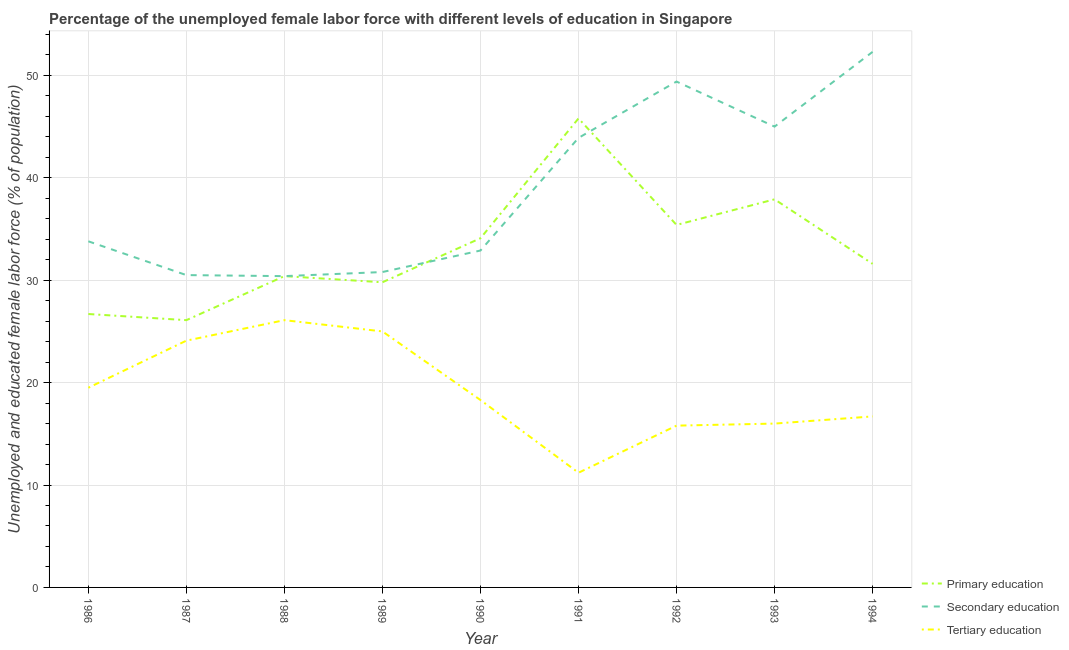What is the percentage of female labor force who received secondary education in 1986?
Your answer should be compact. 33.8. Across all years, what is the maximum percentage of female labor force who received secondary education?
Your answer should be compact. 52.3. Across all years, what is the minimum percentage of female labor force who received secondary education?
Your answer should be very brief. 30.4. In which year was the percentage of female labor force who received primary education maximum?
Your answer should be compact. 1991. What is the total percentage of female labor force who received tertiary education in the graph?
Offer a very short reply. 172.7. What is the difference between the percentage of female labor force who received primary education in 1988 and that in 1991?
Make the answer very short. -15.4. What is the difference between the percentage of female labor force who received tertiary education in 1988 and the percentage of female labor force who received primary education in 1987?
Offer a very short reply. 0. What is the average percentage of female labor force who received primary education per year?
Keep it short and to the point. 33.09. In the year 1990, what is the difference between the percentage of female labor force who received primary education and percentage of female labor force who received tertiary education?
Your answer should be very brief. 15.8. What is the ratio of the percentage of female labor force who received primary education in 1986 to that in 1994?
Your answer should be compact. 0.84. Is the difference between the percentage of female labor force who received tertiary education in 1987 and 1988 greater than the difference between the percentage of female labor force who received primary education in 1987 and 1988?
Keep it short and to the point. Yes. What is the difference between the highest and the second highest percentage of female labor force who received tertiary education?
Give a very brief answer. 1.1. What is the difference between the highest and the lowest percentage of female labor force who received secondary education?
Your answer should be compact. 21.9. In how many years, is the percentage of female labor force who received tertiary education greater than the average percentage of female labor force who received tertiary education taken over all years?
Provide a short and direct response. 4. Is the percentage of female labor force who received tertiary education strictly greater than the percentage of female labor force who received secondary education over the years?
Provide a short and direct response. No. Does the graph contain any zero values?
Provide a short and direct response. No. How are the legend labels stacked?
Offer a very short reply. Vertical. What is the title of the graph?
Your answer should be compact. Percentage of the unemployed female labor force with different levels of education in Singapore. What is the label or title of the X-axis?
Offer a terse response. Year. What is the label or title of the Y-axis?
Offer a terse response. Unemployed and educated female labor force (% of population). What is the Unemployed and educated female labor force (% of population) of Primary education in 1986?
Give a very brief answer. 26.7. What is the Unemployed and educated female labor force (% of population) of Secondary education in 1986?
Provide a short and direct response. 33.8. What is the Unemployed and educated female labor force (% of population) in Primary education in 1987?
Make the answer very short. 26.1. What is the Unemployed and educated female labor force (% of population) of Secondary education in 1987?
Keep it short and to the point. 30.5. What is the Unemployed and educated female labor force (% of population) in Tertiary education in 1987?
Give a very brief answer. 24.1. What is the Unemployed and educated female labor force (% of population) of Primary education in 1988?
Make the answer very short. 30.4. What is the Unemployed and educated female labor force (% of population) in Secondary education in 1988?
Your response must be concise. 30.4. What is the Unemployed and educated female labor force (% of population) in Tertiary education in 1988?
Your response must be concise. 26.1. What is the Unemployed and educated female labor force (% of population) in Primary education in 1989?
Your response must be concise. 29.8. What is the Unemployed and educated female labor force (% of population) of Secondary education in 1989?
Your answer should be very brief. 30.8. What is the Unemployed and educated female labor force (% of population) in Primary education in 1990?
Provide a short and direct response. 34.1. What is the Unemployed and educated female labor force (% of population) of Secondary education in 1990?
Your answer should be compact. 32.9. What is the Unemployed and educated female labor force (% of population) of Tertiary education in 1990?
Offer a terse response. 18.3. What is the Unemployed and educated female labor force (% of population) in Primary education in 1991?
Your answer should be very brief. 45.8. What is the Unemployed and educated female labor force (% of population) in Secondary education in 1991?
Your response must be concise. 43.9. What is the Unemployed and educated female labor force (% of population) in Tertiary education in 1991?
Offer a terse response. 11.2. What is the Unemployed and educated female labor force (% of population) in Primary education in 1992?
Make the answer very short. 35.4. What is the Unemployed and educated female labor force (% of population) of Secondary education in 1992?
Your answer should be compact. 49.4. What is the Unemployed and educated female labor force (% of population) of Tertiary education in 1992?
Offer a terse response. 15.8. What is the Unemployed and educated female labor force (% of population) of Primary education in 1993?
Offer a very short reply. 37.9. What is the Unemployed and educated female labor force (% of population) in Secondary education in 1993?
Your answer should be compact. 45. What is the Unemployed and educated female labor force (% of population) in Primary education in 1994?
Offer a very short reply. 31.6. What is the Unemployed and educated female labor force (% of population) of Secondary education in 1994?
Offer a terse response. 52.3. What is the Unemployed and educated female labor force (% of population) of Tertiary education in 1994?
Keep it short and to the point. 16.7. Across all years, what is the maximum Unemployed and educated female labor force (% of population) of Primary education?
Your answer should be compact. 45.8. Across all years, what is the maximum Unemployed and educated female labor force (% of population) in Secondary education?
Provide a succinct answer. 52.3. Across all years, what is the maximum Unemployed and educated female labor force (% of population) of Tertiary education?
Your answer should be very brief. 26.1. Across all years, what is the minimum Unemployed and educated female labor force (% of population) of Primary education?
Your answer should be compact. 26.1. Across all years, what is the minimum Unemployed and educated female labor force (% of population) in Secondary education?
Offer a terse response. 30.4. Across all years, what is the minimum Unemployed and educated female labor force (% of population) of Tertiary education?
Your response must be concise. 11.2. What is the total Unemployed and educated female labor force (% of population) of Primary education in the graph?
Your answer should be very brief. 297.8. What is the total Unemployed and educated female labor force (% of population) of Secondary education in the graph?
Ensure brevity in your answer.  349. What is the total Unemployed and educated female labor force (% of population) of Tertiary education in the graph?
Provide a succinct answer. 172.7. What is the difference between the Unemployed and educated female labor force (% of population) in Secondary education in 1986 and that in 1987?
Your answer should be compact. 3.3. What is the difference between the Unemployed and educated female labor force (% of population) of Primary education in 1986 and that in 1988?
Offer a terse response. -3.7. What is the difference between the Unemployed and educated female labor force (% of population) in Secondary education in 1986 and that in 1988?
Give a very brief answer. 3.4. What is the difference between the Unemployed and educated female labor force (% of population) of Tertiary education in 1986 and that in 1988?
Your answer should be very brief. -6.6. What is the difference between the Unemployed and educated female labor force (% of population) of Secondary education in 1986 and that in 1989?
Your answer should be compact. 3. What is the difference between the Unemployed and educated female labor force (% of population) of Tertiary education in 1986 and that in 1989?
Provide a succinct answer. -5.5. What is the difference between the Unemployed and educated female labor force (% of population) in Primary education in 1986 and that in 1990?
Your answer should be compact. -7.4. What is the difference between the Unemployed and educated female labor force (% of population) in Primary education in 1986 and that in 1991?
Ensure brevity in your answer.  -19.1. What is the difference between the Unemployed and educated female labor force (% of population) of Tertiary education in 1986 and that in 1991?
Your answer should be compact. 8.3. What is the difference between the Unemployed and educated female labor force (% of population) of Primary education in 1986 and that in 1992?
Offer a very short reply. -8.7. What is the difference between the Unemployed and educated female labor force (% of population) in Secondary education in 1986 and that in 1992?
Your answer should be very brief. -15.6. What is the difference between the Unemployed and educated female labor force (% of population) in Secondary education in 1986 and that in 1993?
Your answer should be compact. -11.2. What is the difference between the Unemployed and educated female labor force (% of population) of Tertiary education in 1986 and that in 1993?
Your answer should be very brief. 3.5. What is the difference between the Unemployed and educated female labor force (% of population) in Secondary education in 1986 and that in 1994?
Provide a short and direct response. -18.5. What is the difference between the Unemployed and educated female labor force (% of population) in Secondary education in 1987 and that in 1988?
Ensure brevity in your answer.  0.1. What is the difference between the Unemployed and educated female labor force (% of population) of Tertiary education in 1987 and that in 1988?
Keep it short and to the point. -2. What is the difference between the Unemployed and educated female labor force (% of population) in Secondary education in 1987 and that in 1989?
Make the answer very short. -0.3. What is the difference between the Unemployed and educated female labor force (% of population) in Tertiary education in 1987 and that in 1989?
Keep it short and to the point. -0.9. What is the difference between the Unemployed and educated female labor force (% of population) in Primary education in 1987 and that in 1990?
Your answer should be very brief. -8. What is the difference between the Unemployed and educated female labor force (% of population) in Primary education in 1987 and that in 1991?
Offer a terse response. -19.7. What is the difference between the Unemployed and educated female labor force (% of population) in Primary education in 1987 and that in 1992?
Keep it short and to the point. -9.3. What is the difference between the Unemployed and educated female labor force (% of population) in Secondary education in 1987 and that in 1992?
Keep it short and to the point. -18.9. What is the difference between the Unemployed and educated female labor force (% of population) in Tertiary education in 1987 and that in 1993?
Make the answer very short. 8.1. What is the difference between the Unemployed and educated female labor force (% of population) of Primary education in 1987 and that in 1994?
Offer a terse response. -5.5. What is the difference between the Unemployed and educated female labor force (% of population) in Secondary education in 1987 and that in 1994?
Your answer should be very brief. -21.8. What is the difference between the Unemployed and educated female labor force (% of population) of Primary education in 1988 and that in 1989?
Make the answer very short. 0.6. What is the difference between the Unemployed and educated female labor force (% of population) in Primary education in 1988 and that in 1990?
Ensure brevity in your answer.  -3.7. What is the difference between the Unemployed and educated female labor force (% of population) in Tertiary education in 1988 and that in 1990?
Keep it short and to the point. 7.8. What is the difference between the Unemployed and educated female labor force (% of population) of Primary education in 1988 and that in 1991?
Make the answer very short. -15.4. What is the difference between the Unemployed and educated female labor force (% of population) of Secondary education in 1988 and that in 1991?
Keep it short and to the point. -13.5. What is the difference between the Unemployed and educated female labor force (% of population) of Tertiary education in 1988 and that in 1991?
Provide a succinct answer. 14.9. What is the difference between the Unemployed and educated female labor force (% of population) in Primary education in 1988 and that in 1992?
Give a very brief answer. -5. What is the difference between the Unemployed and educated female labor force (% of population) of Tertiary education in 1988 and that in 1992?
Offer a very short reply. 10.3. What is the difference between the Unemployed and educated female labor force (% of population) in Secondary education in 1988 and that in 1993?
Keep it short and to the point. -14.6. What is the difference between the Unemployed and educated female labor force (% of population) in Primary education in 1988 and that in 1994?
Give a very brief answer. -1.2. What is the difference between the Unemployed and educated female labor force (% of population) of Secondary education in 1988 and that in 1994?
Offer a very short reply. -21.9. What is the difference between the Unemployed and educated female labor force (% of population) in Tertiary education in 1989 and that in 1990?
Offer a terse response. 6.7. What is the difference between the Unemployed and educated female labor force (% of population) of Secondary education in 1989 and that in 1991?
Make the answer very short. -13.1. What is the difference between the Unemployed and educated female labor force (% of population) in Tertiary education in 1989 and that in 1991?
Ensure brevity in your answer.  13.8. What is the difference between the Unemployed and educated female labor force (% of population) in Secondary education in 1989 and that in 1992?
Your answer should be compact. -18.6. What is the difference between the Unemployed and educated female labor force (% of population) of Tertiary education in 1989 and that in 1992?
Keep it short and to the point. 9.2. What is the difference between the Unemployed and educated female labor force (% of population) in Primary education in 1989 and that in 1993?
Your response must be concise. -8.1. What is the difference between the Unemployed and educated female labor force (% of population) in Secondary education in 1989 and that in 1994?
Give a very brief answer. -21.5. What is the difference between the Unemployed and educated female labor force (% of population) of Primary education in 1990 and that in 1991?
Provide a short and direct response. -11.7. What is the difference between the Unemployed and educated female labor force (% of population) of Secondary education in 1990 and that in 1992?
Offer a terse response. -16.5. What is the difference between the Unemployed and educated female labor force (% of population) of Tertiary education in 1990 and that in 1992?
Offer a terse response. 2.5. What is the difference between the Unemployed and educated female labor force (% of population) of Primary education in 1990 and that in 1993?
Ensure brevity in your answer.  -3.8. What is the difference between the Unemployed and educated female labor force (% of population) in Secondary education in 1990 and that in 1993?
Your answer should be compact. -12.1. What is the difference between the Unemployed and educated female labor force (% of population) of Tertiary education in 1990 and that in 1993?
Give a very brief answer. 2.3. What is the difference between the Unemployed and educated female labor force (% of population) in Secondary education in 1990 and that in 1994?
Give a very brief answer. -19.4. What is the difference between the Unemployed and educated female labor force (% of population) in Tertiary education in 1991 and that in 1992?
Ensure brevity in your answer.  -4.6. What is the difference between the Unemployed and educated female labor force (% of population) in Primary education in 1991 and that in 1993?
Keep it short and to the point. 7.9. What is the difference between the Unemployed and educated female labor force (% of population) of Secondary education in 1991 and that in 1994?
Ensure brevity in your answer.  -8.4. What is the difference between the Unemployed and educated female labor force (% of population) in Primary education in 1992 and that in 1993?
Keep it short and to the point. -2.5. What is the difference between the Unemployed and educated female labor force (% of population) in Secondary education in 1992 and that in 1994?
Provide a succinct answer. -2.9. What is the difference between the Unemployed and educated female labor force (% of population) in Tertiary education in 1992 and that in 1994?
Give a very brief answer. -0.9. What is the difference between the Unemployed and educated female labor force (% of population) in Primary education in 1986 and the Unemployed and educated female labor force (% of population) in Tertiary education in 1987?
Make the answer very short. 2.6. What is the difference between the Unemployed and educated female labor force (% of population) in Primary education in 1986 and the Unemployed and educated female labor force (% of population) in Secondary education in 1988?
Your response must be concise. -3.7. What is the difference between the Unemployed and educated female labor force (% of population) in Primary education in 1986 and the Unemployed and educated female labor force (% of population) in Tertiary education in 1988?
Your answer should be compact. 0.6. What is the difference between the Unemployed and educated female labor force (% of population) in Primary education in 1986 and the Unemployed and educated female labor force (% of population) in Tertiary education in 1989?
Provide a short and direct response. 1.7. What is the difference between the Unemployed and educated female labor force (% of population) in Secondary education in 1986 and the Unemployed and educated female labor force (% of population) in Tertiary education in 1989?
Provide a short and direct response. 8.8. What is the difference between the Unemployed and educated female labor force (% of population) in Primary education in 1986 and the Unemployed and educated female labor force (% of population) in Secondary education in 1991?
Your answer should be compact. -17.2. What is the difference between the Unemployed and educated female labor force (% of population) of Secondary education in 1986 and the Unemployed and educated female labor force (% of population) of Tertiary education in 1991?
Give a very brief answer. 22.6. What is the difference between the Unemployed and educated female labor force (% of population) of Primary education in 1986 and the Unemployed and educated female labor force (% of population) of Secondary education in 1992?
Provide a succinct answer. -22.7. What is the difference between the Unemployed and educated female labor force (% of population) in Primary education in 1986 and the Unemployed and educated female labor force (% of population) in Tertiary education in 1992?
Ensure brevity in your answer.  10.9. What is the difference between the Unemployed and educated female labor force (% of population) of Primary education in 1986 and the Unemployed and educated female labor force (% of population) of Secondary education in 1993?
Give a very brief answer. -18.3. What is the difference between the Unemployed and educated female labor force (% of population) in Primary education in 1986 and the Unemployed and educated female labor force (% of population) in Tertiary education in 1993?
Offer a terse response. 10.7. What is the difference between the Unemployed and educated female labor force (% of population) of Secondary education in 1986 and the Unemployed and educated female labor force (% of population) of Tertiary education in 1993?
Offer a terse response. 17.8. What is the difference between the Unemployed and educated female labor force (% of population) of Primary education in 1986 and the Unemployed and educated female labor force (% of population) of Secondary education in 1994?
Offer a very short reply. -25.6. What is the difference between the Unemployed and educated female labor force (% of population) of Primary education in 1987 and the Unemployed and educated female labor force (% of population) of Secondary education in 1988?
Your answer should be compact. -4.3. What is the difference between the Unemployed and educated female labor force (% of population) of Primary education in 1987 and the Unemployed and educated female labor force (% of population) of Secondary education in 1989?
Make the answer very short. -4.7. What is the difference between the Unemployed and educated female labor force (% of population) of Primary education in 1987 and the Unemployed and educated female labor force (% of population) of Tertiary education in 1989?
Keep it short and to the point. 1.1. What is the difference between the Unemployed and educated female labor force (% of population) of Secondary education in 1987 and the Unemployed and educated female labor force (% of population) of Tertiary education in 1989?
Make the answer very short. 5.5. What is the difference between the Unemployed and educated female labor force (% of population) in Primary education in 1987 and the Unemployed and educated female labor force (% of population) in Tertiary education in 1990?
Provide a short and direct response. 7.8. What is the difference between the Unemployed and educated female labor force (% of population) of Primary education in 1987 and the Unemployed and educated female labor force (% of population) of Secondary education in 1991?
Keep it short and to the point. -17.8. What is the difference between the Unemployed and educated female labor force (% of population) of Primary education in 1987 and the Unemployed and educated female labor force (% of population) of Tertiary education in 1991?
Your response must be concise. 14.9. What is the difference between the Unemployed and educated female labor force (% of population) of Secondary education in 1987 and the Unemployed and educated female labor force (% of population) of Tertiary education in 1991?
Give a very brief answer. 19.3. What is the difference between the Unemployed and educated female labor force (% of population) of Primary education in 1987 and the Unemployed and educated female labor force (% of population) of Secondary education in 1992?
Your response must be concise. -23.3. What is the difference between the Unemployed and educated female labor force (% of population) of Secondary education in 1987 and the Unemployed and educated female labor force (% of population) of Tertiary education in 1992?
Provide a short and direct response. 14.7. What is the difference between the Unemployed and educated female labor force (% of population) of Primary education in 1987 and the Unemployed and educated female labor force (% of population) of Secondary education in 1993?
Make the answer very short. -18.9. What is the difference between the Unemployed and educated female labor force (% of population) of Secondary education in 1987 and the Unemployed and educated female labor force (% of population) of Tertiary education in 1993?
Keep it short and to the point. 14.5. What is the difference between the Unemployed and educated female labor force (% of population) of Primary education in 1987 and the Unemployed and educated female labor force (% of population) of Secondary education in 1994?
Make the answer very short. -26.2. What is the difference between the Unemployed and educated female labor force (% of population) of Secondary education in 1987 and the Unemployed and educated female labor force (% of population) of Tertiary education in 1994?
Offer a terse response. 13.8. What is the difference between the Unemployed and educated female labor force (% of population) in Primary education in 1988 and the Unemployed and educated female labor force (% of population) in Tertiary education in 1989?
Offer a terse response. 5.4. What is the difference between the Unemployed and educated female labor force (% of population) in Secondary education in 1988 and the Unemployed and educated female labor force (% of population) in Tertiary education in 1990?
Your response must be concise. 12.1. What is the difference between the Unemployed and educated female labor force (% of population) of Primary education in 1988 and the Unemployed and educated female labor force (% of population) of Secondary education in 1992?
Keep it short and to the point. -19. What is the difference between the Unemployed and educated female labor force (% of population) in Primary education in 1988 and the Unemployed and educated female labor force (% of population) in Tertiary education in 1992?
Offer a very short reply. 14.6. What is the difference between the Unemployed and educated female labor force (% of population) of Secondary education in 1988 and the Unemployed and educated female labor force (% of population) of Tertiary education in 1992?
Make the answer very short. 14.6. What is the difference between the Unemployed and educated female labor force (% of population) of Primary education in 1988 and the Unemployed and educated female labor force (% of population) of Secondary education in 1993?
Your answer should be compact. -14.6. What is the difference between the Unemployed and educated female labor force (% of population) of Primary education in 1988 and the Unemployed and educated female labor force (% of population) of Secondary education in 1994?
Provide a succinct answer. -21.9. What is the difference between the Unemployed and educated female labor force (% of population) in Primary education in 1989 and the Unemployed and educated female labor force (% of population) in Tertiary education in 1990?
Provide a succinct answer. 11.5. What is the difference between the Unemployed and educated female labor force (% of population) in Secondary education in 1989 and the Unemployed and educated female labor force (% of population) in Tertiary education in 1990?
Offer a very short reply. 12.5. What is the difference between the Unemployed and educated female labor force (% of population) of Primary education in 1989 and the Unemployed and educated female labor force (% of population) of Secondary education in 1991?
Your answer should be compact. -14.1. What is the difference between the Unemployed and educated female labor force (% of population) in Primary education in 1989 and the Unemployed and educated female labor force (% of population) in Tertiary education in 1991?
Offer a terse response. 18.6. What is the difference between the Unemployed and educated female labor force (% of population) of Secondary education in 1989 and the Unemployed and educated female labor force (% of population) of Tertiary education in 1991?
Give a very brief answer. 19.6. What is the difference between the Unemployed and educated female labor force (% of population) in Primary education in 1989 and the Unemployed and educated female labor force (% of population) in Secondary education in 1992?
Your answer should be compact. -19.6. What is the difference between the Unemployed and educated female labor force (% of population) of Primary education in 1989 and the Unemployed and educated female labor force (% of population) of Tertiary education in 1992?
Provide a short and direct response. 14. What is the difference between the Unemployed and educated female labor force (% of population) of Secondary education in 1989 and the Unemployed and educated female labor force (% of population) of Tertiary education in 1992?
Your response must be concise. 15. What is the difference between the Unemployed and educated female labor force (% of population) of Primary education in 1989 and the Unemployed and educated female labor force (% of population) of Secondary education in 1993?
Your answer should be compact. -15.2. What is the difference between the Unemployed and educated female labor force (% of population) of Primary education in 1989 and the Unemployed and educated female labor force (% of population) of Tertiary education in 1993?
Make the answer very short. 13.8. What is the difference between the Unemployed and educated female labor force (% of population) of Secondary education in 1989 and the Unemployed and educated female labor force (% of population) of Tertiary education in 1993?
Make the answer very short. 14.8. What is the difference between the Unemployed and educated female labor force (% of population) of Primary education in 1989 and the Unemployed and educated female labor force (% of population) of Secondary education in 1994?
Your response must be concise. -22.5. What is the difference between the Unemployed and educated female labor force (% of population) in Primary education in 1989 and the Unemployed and educated female labor force (% of population) in Tertiary education in 1994?
Your answer should be compact. 13.1. What is the difference between the Unemployed and educated female labor force (% of population) in Primary education in 1990 and the Unemployed and educated female labor force (% of population) in Secondary education in 1991?
Offer a terse response. -9.8. What is the difference between the Unemployed and educated female labor force (% of population) of Primary education in 1990 and the Unemployed and educated female labor force (% of population) of Tertiary education in 1991?
Offer a very short reply. 22.9. What is the difference between the Unemployed and educated female labor force (% of population) in Secondary education in 1990 and the Unemployed and educated female labor force (% of population) in Tertiary education in 1991?
Provide a succinct answer. 21.7. What is the difference between the Unemployed and educated female labor force (% of population) in Primary education in 1990 and the Unemployed and educated female labor force (% of population) in Secondary education in 1992?
Your answer should be very brief. -15.3. What is the difference between the Unemployed and educated female labor force (% of population) of Secondary education in 1990 and the Unemployed and educated female labor force (% of population) of Tertiary education in 1992?
Provide a succinct answer. 17.1. What is the difference between the Unemployed and educated female labor force (% of population) in Primary education in 1990 and the Unemployed and educated female labor force (% of population) in Tertiary education in 1993?
Ensure brevity in your answer.  18.1. What is the difference between the Unemployed and educated female labor force (% of population) in Primary education in 1990 and the Unemployed and educated female labor force (% of population) in Secondary education in 1994?
Provide a short and direct response. -18.2. What is the difference between the Unemployed and educated female labor force (% of population) of Primary education in 1990 and the Unemployed and educated female labor force (% of population) of Tertiary education in 1994?
Make the answer very short. 17.4. What is the difference between the Unemployed and educated female labor force (% of population) in Secondary education in 1990 and the Unemployed and educated female labor force (% of population) in Tertiary education in 1994?
Offer a terse response. 16.2. What is the difference between the Unemployed and educated female labor force (% of population) of Primary education in 1991 and the Unemployed and educated female labor force (% of population) of Secondary education in 1992?
Keep it short and to the point. -3.6. What is the difference between the Unemployed and educated female labor force (% of population) of Secondary education in 1991 and the Unemployed and educated female labor force (% of population) of Tertiary education in 1992?
Your answer should be compact. 28.1. What is the difference between the Unemployed and educated female labor force (% of population) in Primary education in 1991 and the Unemployed and educated female labor force (% of population) in Tertiary education in 1993?
Provide a succinct answer. 29.8. What is the difference between the Unemployed and educated female labor force (% of population) in Secondary education in 1991 and the Unemployed and educated female labor force (% of population) in Tertiary education in 1993?
Offer a very short reply. 27.9. What is the difference between the Unemployed and educated female labor force (% of population) of Primary education in 1991 and the Unemployed and educated female labor force (% of population) of Tertiary education in 1994?
Provide a short and direct response. 29.1. What is the difference between the Unemployed and educated female labor force (% of population) of Secondary education in 1991 and the Unemployed and educated female labor force (% of population) of Tertiary education in 1994?
Keep it short and to the point. 27.2. What is the difference between the Unemployed and educated female labor force (% of population) in Primary education in 1992 and the Unemployed and educated female labor force (% of population) in Tertiary education in 1993?
Offer a very short reply. 19.4. What is the difference between the Unemployed and educated female labor force (% of population) of Secondary education in 1992 and the Unemployed and educated female labor force (% of population) of Tertiary education in 1993?
Your response must be concise. 33.4. What is the difference between the Unemployed and educated female labor force (% of population) in Primary education in 1992 and the Unemployed and educated female labor force (% of population) in Secondary education in 1994?
Make the answer very short. -16.9. What is the difference between the Unemployed and educated female labor force (% of population) in Secondary education in 1992 and the Unemployed and educated female labor force (% of population) in Tertiary education in 1994?
Make the answer very short. 32.7. What is the difference between the Unemployed and educated female labor force (% of population) in Primary education in 1993 and the Unemployed and educated female labor force (% of population) in Secondary education in 1994?
Keep it short and to the point. -14.4. What is the difference between the Unemployed and educated female labor force (% of population) in Primary education in 1993 and the Unemployed and educated female labor force (% of population) in Tertiary education in 1994?
Provide a succinct answer. 21.2. What is the difference between the Unemployed and educated female labor force (% of population) of Secondary education in 1993 and the Unemployed and educated female labor force (% of population) of Tertiary education in 1994?
Offer a terse response. 28.3. What is the average Unemployed and educated female labor force (% of population) in Primary education per year?
Offer a very short reply. 33.09. What is the average Unemployed and educated female labor force (% of population) in Secondary education per year?
Provide a succinct answer. 38.78. What is the average Unemployed and educated female labor force (% of population) of Tertiary education per year?
Offer a very short reply. 19.19. In the year 1986, what is the difference between the Unemployed and educated female labor force (% of population) in Primary education and Unemployed and educated female labor force (% of population) in Secondary education?
Your answer should be compact. -7.1. In the year 1986, what is the difference between the Unemployed and educated female labor force (% of population) in Primary education and Unemployed and educated female labor force (% of population) in Tertiary education?
Provide a succinct answer. 7.2. In the year 1986, what is the difference between the Unemployed and educated female labor force (% of population) in Secondary education and Unemployed and educated female labor force (% of population) in Tertiary education?
Offer a terse response. 14.3. In the year 1987, what is the difference between the Unemployed and educated female labor force (% of population) of Secondary education and Unemployed and educated female labor force (% of population) of Tertiary education?
Make the answer very short. 6.4. In the year 1988, what is the difference between the Unemployed and educated female labor force (% of population) of Primary education and Unemployed and educated female labor force (% of population) of Secondary education?
Your response must be concise. 0. In the year 1988, what is the difference between the Unemployed and educated female labor force (% of population) of Secondary education and Unemployed and educated female labor force (% of population) of Tertiary education?
Offer a very short reply. 4.3. In the year 1989, what is the difference between the Unemployed and educated female labor force (% of population) in Primary education and Unemployed and educated female labor force (% of population) in Secondary education?
Provide a short and direct response. -1. In the year 1989, what is the difference between the Unemployed and educated female labor force (% of population) of Primary education and Unemployed and educated female labor force (% of population) of Tertiary education?
Keep it short and to the point. 4.8. In the year 1989, what is the difference between the Unemployed and educated female labor force (% of population) in Secondary education and Unemployed and educated female labor force (% of population) in Tertiary education?
Your answer should be compact. 5.8. In the year 1990, what is the difference between the Unemployed and educated female labor force (% of population) of Primary education and Unemployed and educated female labor force (% of population) of Tertiary education?
Make the answer very short. 15.8. In the year 1991, what is the difference between the Unemployed and educated female labor force (% of population) in Primary education and Unemployed and educated female labor force (% of population) in Secondary education?
Keep it short and to the point. 1.9. In the year 1991, what is the difference between the Unemployed and educated female labor force (% of population) in Primary education and Unemployed and educated female labor force (% of population) in Tertiary education?
Keep it short and to the point. 34.6. In the year 1991, what is the difference between the Unemployed and educated female labor force (% of population) of Secondary education and Unemployed and educated female labor force (% of population) of Tertiary education?
Your answer should be very brief. 32.7. In the year 1992, what is the difference between the Unemployed and educated female labor force (% of population) in Primary education and Unemployed and educated female labor force (% of population) in Tertiary education?
Provide a short and direct response. 19.6. In the year 1992, what is the difference between the Unemployed and educated female labor force (% of population) in Secondary education and Unemployed and educated female labor force (% of population) in Tertiary education?
Provide a short and direct response. 33.6. In the year 1993, what is the difference between the Unemployed and educated female labor force (% of population) of Primary education and Unemployed and educated female labor force (% of population) of Secondary education?
Provide a short and direct response. -7.1. In the year 1993, what is the difference between the Unemployed and educated female labor force (% of population) in Primary education and Unemployed and educated female labor force (% of population) in Tertiary education?
Your response must be concise. 21.9. In the year 1994, what is the difference between the Unemployed and educated female labor force (% of population) in Primary education and Unemployed and educated female labor force (% of population) in Secondary education?
Offer a terse response. -20.7. In the year 1994, what is the difference between the Unemployed and educated female labor force (% of population) in Primary education and Unemployed and educated female labor force (% of population) in Tertiary education?
Your answer should be very brief. 14.9. In the year 1994, what is the difference between the Unemployed and educated female labor force (% of population) in Secondary education and Unemployed and educated female labor force (% of population) in Tertiary education?
Your answer should be very brief. 35.6. What is the ratio of the Unemployed and educated female labor force (% of population) in Primary education in 1986 to that in 1987?
Your answer should be very brief. 1.02. What is the ratio of the Unemployed and educated female labor force (% of population) in Secondary education in 1986 to that in 1987?
Give a very brief answer. 1.11. What is the ratio of the Unemployed and educated female labor force (% of population) in Tertiary education in 1986 to that in 1987?
Keep it short and to the point. 0.81. What is the ratio of the Unemployed and educated female labor force (% of population) of Primary education in 1986 to that in 1988?
Your answer should be compact. 0.88. What is the ratio of the Unemployed and educated female labor force (% of population) of Secondary education in 1986 to that in 1988?
Provide a short and direct response. 1.11. What is the ratio of the Unemployed and educated female labor force (% of population) in Tertiary education in 1986 to that in 1988?
Give a very brief answer. 0.75. What is the ratio of the Unemployed and educated female labor force (% of population) in Primary education in 1986 to that in 1989?
Your answer should be compact. 0.9. What is the ratio of the Unemployed and educated female labor force (% of population) of Secondary education in 1986 to that in 1989?
Give a very brief answer. 1.1. What is the ratio of the Unemployed and educated female labor force (% of population) in Tertiary education in 1986 to that in 1989?
Your answer should be compact. 0.78. What is the ratio of the Unemployed and educated female labor force (% of population) of Primary education in 1986 to that in 1990?
Make the answer very short. 0.78. What is the ratio of the Unemployed and educated female labor force (% of population) of Secondary education in 1986 to that in 1990?
Provide a short and direct response. 1.03. What is the ratio of the Unemployed and educated female labor force (% of population) of Tertiary education in 1986 to that in 1990?
Make the answer very short. 1.07. What is the ratio of the Unemployed and educated female labor force (% of population) in Primary education in 1986 to that in 1991?
Keep it short and to the point. 0.58. What is the ratio of the Unemployed and educated female labor force (% of population) in Secondary education in 1986 to that in 1991?
Keep it short and to the point. 0.77. What is the ratio of the Unemployed and educated female labor force (% of population) of Tertiary education in 1986 to that in 1991?
Your answer should be compact. 1.74. What is the ratio of the Unemployed and educated female labor force (% of population) in Primary education in 1986 to that in 1992?
Offer a terse response. 0.75. What is the ratio of the Unemployed and educated female labor force (% of population) in Secondary education in 1986 to that in 1992?
Make the answer very short. 0.68. What is the ratio of the Unemployed and educated female labor force (% of population) of Tertiary education in 1986 to that in 1992?
Offer a very short reply. 1.23. What is the ratio of the Unemployed and educated female labor force (% of population) in Primary education in 1986 to that in 1993?
Give a very brief answer. 0.7. What is the ratio of the Unemployed and educated female labor force (% of population) in Secondary education in 1986 to that in 1993?
Your answer should be compact. 0.75. What is the ratio of the Unemployed and educated female labor force (% of population) of Tertiary education in 1986 to that in 1993?
Your answer should be very brief. 1.22. What is the ratio of the Unemployed and educated female labor force (% of population) in Primary education in 1986 to that in 1994?
Offer a very short reply. 0.84. What is the ratio of the Unemployed and educated female labor force (% of population) in Secondary education in 1986 to that in 1994?
Give a very brief answer. 0.65. What is the ratio of the Unemployed and educated female labor force (% of population) in Tertiary education in 1986 to that in 1994?
Keep it short and to the point. 1.17. What is the ratio of the Unemployed and educated female labor force (% of population) in Primary education in 1987 to that in 1988?
Offer a very short reply. 0.86. What is the ratio of the Unemployed and educated female labor force (% of population) of Tertiary education in 1987 to that in 1988?
Make the answer very short. 0.92. What is the ratio of the Unemployed and educated female labor force (% of population) of Primary education in 1987 to that in 1989?
Ensure brevity in your answer.  0.88. What is the ratio of the Unemployed and educated female labor force (% of population) of Secondary education in 1987 to that in 1989?
Your response must be concise. 0.99. What is the ratio of the Unemployed and educated female labor force (% of population) in Primary education in 1987 to that in 1990?
Give a very brief answer. 0.77. What is the ratio of the Unemployed and educated female labor force (% of population) in Secondary education in 1987 to that in 1990?
Make the answer very short. 0.93. What is the ratio of the Unemployed and educated female labor force (% of population) of Tertiary education in 1987 to that in 1990?
Offer a very short reply. 1.32. What is the ratio of the Unemployed and educated female labor force (% of population) in Primary education in 1987 to that in 1991?
Provide a short and direct response. 0.57. What is the ratio of the Unemployed and educated female labor force (% of population) in Secondary education in 1987 to that in 1991?
Provide a succinct answer. 0.69. What is the ratio of the Unemployed and educated female labor force (% of population) in Tertiary education in 1987 to that in 1991?
Provide a short and direct response. 2.15. What is the ratio of the Unemployed and educated female labor force (% of population) of Primary education in 1987 to that in 1992?
Make the answer very short. 0.74. What is the ratio of the Unemployed and educated female labor force (% of population) of Secondary education in 1987 to that in 1992?
Offer a very short reply. 0.62. What is the ratio of the Unemployed and educated female labor force (% of population) of Tertiary education in 1987 to that in 1992?
Keep it short and to the point. 1.53. What is the ratio of the Unemployed and educated female labor force (% of population) in Primary education in 1987 to that in 1993?
Provide a succinct answer. 0.69. What is the ratio of the Unemployed and educated female labor force (% of population) in Secondary education in 1987 to that in 1993?
Give a very brief answer. 0.68. What is the ratio of the Unemployed and educated female labor force (% of population) of Tertiary education in 1987 to that in 1993?
Your answer should be very brief. 1.51. What is the ratio of the Unemployed and educated female labor force (% of population) in Primary education in 1987 to that in 1994?
Offer a terse response. 0.83. What is the ratio of the Unemployed and educated female labor force (% of population) in Secondary education in 1987 to that in 1994?
Provide a succinct answer. 0.58. What is the ratio of the Unemployed and educated female labor force (% of population) of Tertiary education in 1987 to that in 1994?
Keep it short and to the point. 1.44. What is the ratio of the Unemployed and educated female labor force (% of population) in Primary education in 1988 to that in 1989?
Your answer should be compact. 1.02. What is the ratio of the Unemployed and educated female labor force (% of population) in Secondary education in 1988 to that in 1989?
Provide a succinct answer. 0.99. What is the ratio of the Unemployed and educated female labor force (% of population) of Tertiary education in 1988 to that in 1989?
Make the answer very short. 1.04. What is the ratio of the Unemployed and educated female labor force (% of population) in Primary education in 1988 to that in 1990?
Offer a terse response. 0.89. What is the ratio of the Unemployed and educated female labor force (% of population) of Secondary education in 1988 to that in 1990?
Offer a terse response. 0.92. What is the ratio of the Unemployed and educated female labor force (% of population) in Tertiary education in 1988 to that in 1990?
Make the answer very short. 1.43. What is the ratio of the Unemployed and educated female labor force (% of population) in Primary education in 1988 to that in 1991?
Provide a short and direct response. 0.66. What is the ratio of the Unemployed and educated female labor force (% of population) in Secondary education in 1988 to that in 1991?
Provide a succinct answer. 0.69. What is the ratio of the Unemployed and educated female labor force (% of population) of Tertiary education in 1988 to that in 1991?
Offer a very short reply. 2.33. What is the ratio of the Unemployed and educated female labor force (% of population) of Primary education in 1988 to that in 1992?
Ensure brevity in your answer.  0.86. What is the ratio of the Unemployed and educated female labor force (% of population) in Secondary education in 1988 to that in 1992?
Ensure brevity in your answer.  0.62. What is the ratio of the Unemployed and educated female labor force (% of population) in Tertiary education in 1988 to that in 1992?
Make the answer very short. 1.65. What is the ratio of the Unemployed and educated female labor force (% of population) of Primary education in 1988 to that in 1993?
Offer a terse response. 0.8. What is the ratio of the Unemployed and educated female labor force (% of population) in Secondary education in 1988 to that in 1993?
Give a very brief answer. 0.68. What is the ratio of the Unemployed and educated female labor force (% of population) in Tertiary education in 1988 to that in 1993?
Make the answer very short. 1.63. What is the ratio of the Unemployed and educated female labor force (% of population) in Primary education in 1988 to that in 1994?
Offer a very short reply. 0.96. What is the ratio of the Unemployed and educated female labor force (% of population) in Secondary education in 1988 to that in 1994?
Keep it short and to the point. 0.58. What is the ratio of the Unemployed and educated female labor force (% of population) of Tertiary education in 1988 to that in 1994?
Your response must be concise. 1.56. What is the ratio of the Unemployed and educated female labor force (% of population) in Primary education in 1989 to that in 1990?
Your response must be concise. 0.87. What is the ratio of the Unemployed and educated female labor force (% of population) of Secondary education in 1989 to that in 1990?
Offer a very short reply. 0.94. What is the ratio of the Unemployed and educated female labor force (% of population) in Tertiary education in 1989 to that in 1990?
Offer a terse response. 1.37. What is the ratio of the Unemployed and educated female labor force (% of population) of Primary education in 1989 to that in 1991?
Provide a short and direct response. 0.65. What is the ratio of the Unemployed and educated female labor force (% of population) in Secondary education in 1989 to that in 1991?
Make the answer very short. 0.7. What is the ratio of the Unemployed and educated female labor force (% of population) of Tertiary education in 1989 to that in 1991?
Provide a succinct answer. 2.23. What is the ratio of the Unemployed and educated female labor force (% of population) of Primary education in 1989 to that in 1992?
Keep it short and to the point. 0.84. What is the ratio of the Unemployed and educated female labor force (% of population) of Secondary education in 1989 to that in 1992?
Make the answer very short. 0.62. What is the ratio of the Unemployed and educated female labor force (% of population) in Tertiary education in 1989 to that in 1992?
Your answer should be very brief. 1.58. What is the ratio of the Unemployed and educated female labor force (% of population) in Primary education in 1989 to that in 1993?
Ensure brevity in your answer.  0.79. What is the ratio of the Unemployed and educated female labor force (% of population) of Secondary education in 1989 to that in 1993?
Provide a short and direct response. 0.68. What is the ratio of the Unemployed and educated female labor force (% of population) in Tertiary education in 1989 to that in 1993?
Your answer should be compact. 1.56. What is the ratio of the Unemployed and educated female labor force (% of population) of Primary education in 1989 to that in 1994?
Provide a succinct answer. 0.94. What is the ratio of the Unemployed and educated female labor force (% of population) in Secondary education in 1989 to that in 1994?
Provide a short and direct response. 0.59. What is the ratio of the Unemployed and educated female labor force (% of population) of Tertiary education in 1989 to that in 1994?
Provide a succinct answer. 1.5. What is the ratio of the Unemployed and educated female labor force (% of population) in Primary education in 1990 to that in 1991?
Your response must be concise. 0.74. What is the ratio of the Unemployed and educated female labor force (% of population) of Secondary education in 1990 to that in 1991?
Make the answer very short. 0.75. What is the ratio of the Unemployed and educated female labor force (% of population) of Tertiary education in 1990 to that in 1991?
Your response must be concise. 1.63. What is the ratio of the Unemployed and educated female labor force (% of population) in Primary education in 1990 to that in 1992?
Your answer should be very brief. 0.96. What is the ratio of the Unemployed and educated female labor force (% of population) in Secondary education in 1990 to that in 1992?
Provide a short and direct response. 0.67. What is the ratio of the Unemployed and educated female labor force (% of population) in Tertiary education in 1990 to that in 1992?
Your answer should be very brief. 1.16. What is the ratio of the Unemployed and educated female labor force (% of population) in Primary education in 1990 to that in 1993?
Ensure brevity in your answer.  0.9. What is the ratio of the Unemployed and educated female labor force (% of population) of Secondary education in 1990 to that in 1993?
Offer a very short reply. 0.73. What is the ratio of the Unemployed and educated female labor force (% of population) of Tertiary education in 1990 to that in 1993?
Provide a succinct answer. 1.14. What is the ratio of the Unemployed and educated female labor force (% of population) in Primary education in 1990 to that in 1994?
Ensure brevity in your answer.  1.08. What is the ratio of the Unemployed and educated female labor force (% of population) of Secondary education in 1990 to that in 1994?
Keep it short and to the point. 0.63. What is the ratio of the Unemployed and educated female labor force (% of population) of Tertiary education in 1990 to that in 1994?
Make the answer very short. 1.1. What is the ratio of the Unemployed and educated female labor force (% of population) of Primary education in 1991 to that in 1992?
Your answer should be very brief. 1.29. What is the ratio of the Unemployed and educated female labor force (% of population) of Secondary education in 1991 to that in 1992?
Your response must be concise. 0.89. What is the ratio of the Unemployed and educated female labor force (% of population) in Tertiary education in 1991 to that in 1992?
Make the answer very short. 0.71. What is the ratio of the Unemployed and educated female labor force (% of population) of Primary education in 1991 to that in 1993?
Your response must be concise. 1.21. What is the ratio of the Unemployed and educated female labor force (% of population) of Secondary education in 1991 to that in 1993?
Give a very brief answer. 0.98. What is the ratio of the Unemployed and educated female labor force (% of population) in Primary education in 1991 to that in 1994?
Keep it short and to the point. 1.45. What is the ratio of the Unemployed and educated female labor force (% of population) in Secondary education in 1991 to that in 1994?
Offer a terse response. 0.84. What is the ratio of the Unemployed and educated female labor force (% of population) of Tertiary education in 1991 to that in 1994?
Your answer should be compact. 0.67. What is the ratio of the Unemployed and educated female labor force (% of population) in Primary education in 1992 to that in 1993?
Offer a very short reply. 0.93. What is the ratio of the Unemployed and educated female labor force (% of population) of Secondary education in 1992 to that in 1993?
Make the answer very short. 1.1. What is the ratio of the Unemployed and educated female labor force (% of population) in Tertiary education in 1992 to that in 1993?
Your response must be concise. 0.99. What is the ratio of the Unemployed and educated female labor force (% of population) of Primary education in 1992 to that in 1994?
Keep it short and to the point. 1.12. What is the ratio of the Unemployed and educated female labor force (% of population) in Secondary education in 1992 to that in 1994?
Provide a succinct answer. 0.94. What is the ratio of the Unemployed and educated female labor force (% of population) in Tertiary education in 1992 to that in 1994?
Your answer should be very brief. 0.95. What is the ratio of the Unemployed and educated female labor force (% of population) of Primary education in 1993 to that in 1994?
Ensure brevity in your answer.  1.2. What is the ratio of the Unemployed and educated female labor force (% of population) of Secondary education in 1993 to that in 1994?
Ensure brevity in your answer.  0.86. What is the ratio of the Unemployed and educated female labor force (% of population) of Tertiary education in 1993 to that in 1994?
Give a very brief answer. 0.96. What is the difference between the highest and the lowest Unemployed and educated female labor force (% of population) in Primary education?
Make the answer very short. 19.7. What is the difference between the highest and the lowest Unemployed and educated female labor force (% of population) of Secondary education?
Make the answer very short. 21.9. What is the difference between the highest and the lowest Unemployed and educated female labor force (% of population) of Tertiary education?
Your response must be concise. 14.9. 